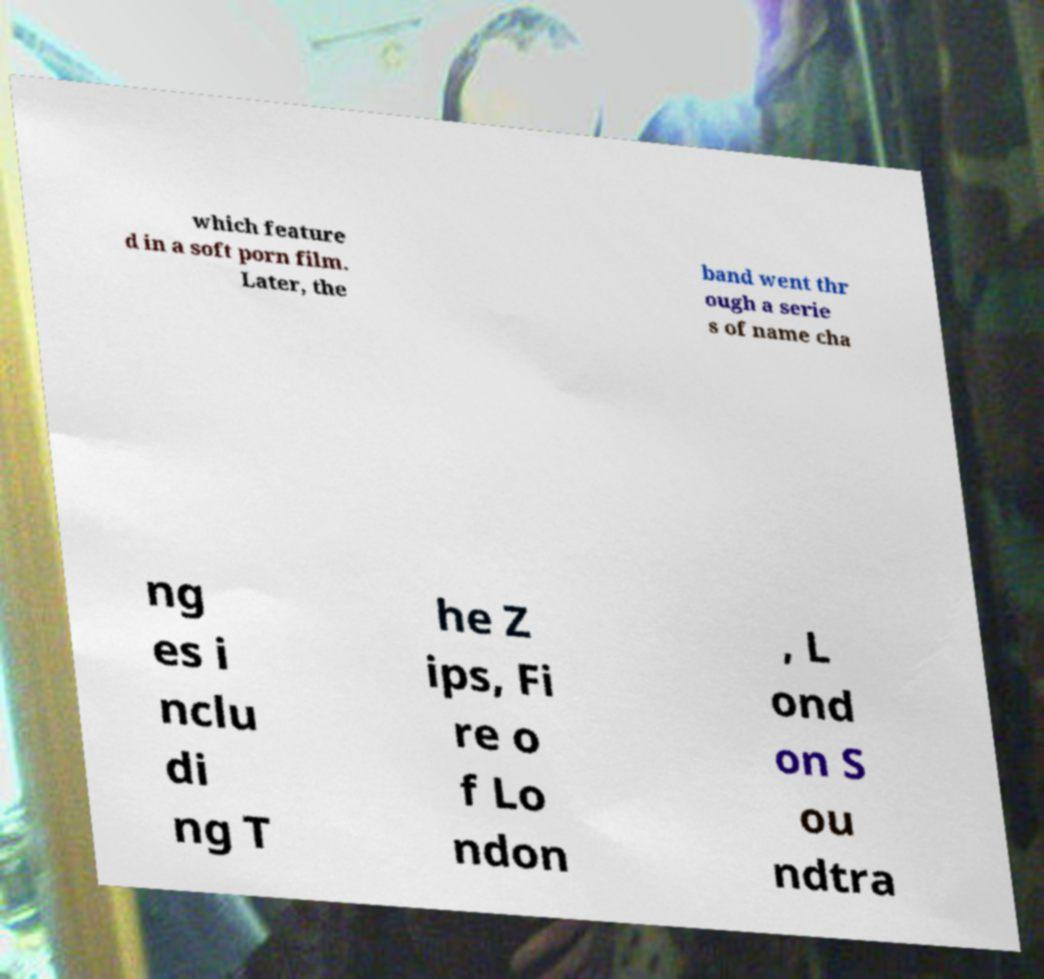Can you read and provide the text displayed in the image?This photo seems to have some interesting text. Can you extract and type it out for me? which feature d in a soft porn film. Later, the band went thr ough a serie s of name cha ng es i nclu di ng T he Z ips, Fi re o f Lo ndon , L ond on S ou ndtra 